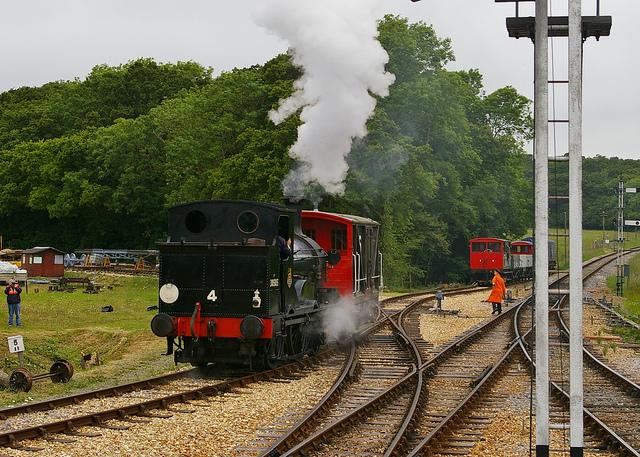Why is the man wearing an orange jacket?

Choices:
A) visibility
B) dress code
C) camouflage
D) fashion visibility 